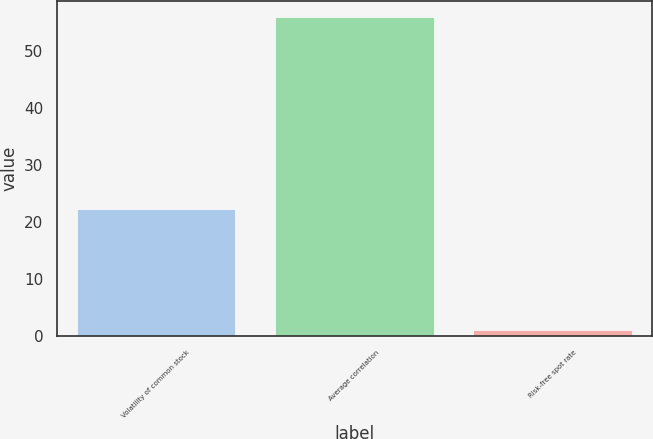<chart> <loc_0><loc_0><loc_500><loc_500><bar_chart><fcel>Volatility of common stock<fcel>Average correlation<fcel>Risk-free spot rate<nl><fcel>22.2<fcel>56<fcel>1<nl></chart> 